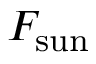Convert formula to latex. <formula><loc_0><loc_0><loc_500><loc_500>F _ { s u n }</formula> 